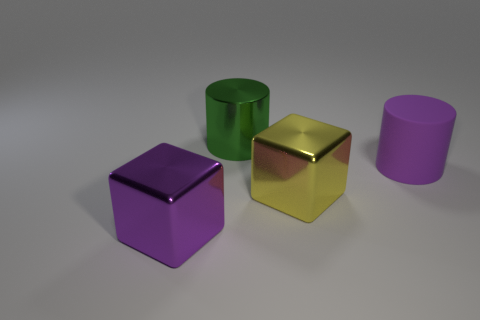Add 4 cyan balls. How many objects exist? 8 Subtract all matte spheres. Subtract all rubber things. How many objects are left? 3 Add 1 green metal things. How many green metal things are left? 2 Add 3 large shiny blocks. How many large shiny blocks exist? 5 Subtract 1 yellow blocks. How many objects are left? 3 